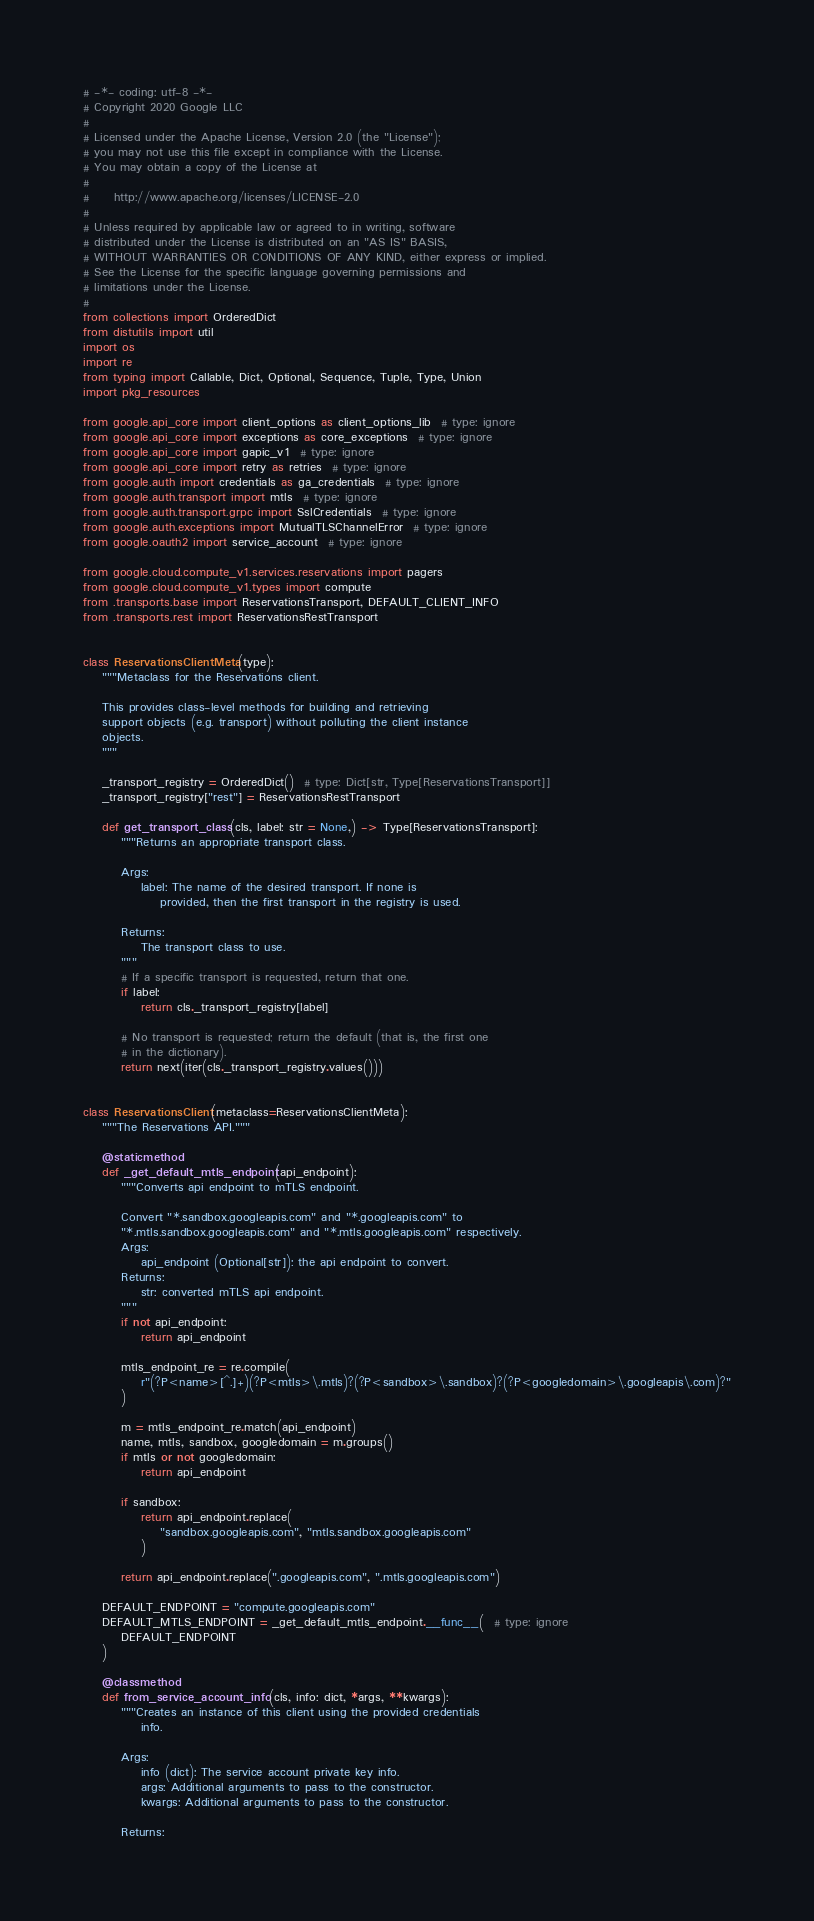Convert code to text. <code><loc_0><loc_0><loc_500><loc_500><_Python_># -*- coding: utf-8 -*-
# Copyright 2020 Google LLC
#
# Licensed under the Apache License, Version 2.0 (the "License");
# you may not use this file except in compliance with the License.
# You may obtain a copy of the License at
#
#     http://www.apache.org/licenses/LICENSE-2.0
#
# Unless required by applicable law or agreed to in writing, software
# distributed under the License is distributed on an "AS IS" BASIS,
# WITHOUT WARRANTIES OR CONDITIONS OF ANY KIND, either express or implied.
# See the License for the specific language governing permissions and
# limitations under the License.
#
from collections import OrderedDict
from distutils import util
import os
import re
from typing import Callable, Dict, Optional, Sequence, Tuple, Type, Union
import pkg_resources

from google.api_core import client_options as client_options_lib  # type: ignore
from google.api_core import exceptions as core_exceptions  # type: ignore
from google.api_core import gapic_v1  # type: ignore
from google.api_core import retry as retries  # type: ignore
from google.auth import credentials as ga_credentials  # type: ignore
from google.auth.transport import mtls  # type: ignore
from google.auth.transport.grpc import SslCredentials  # type: ignore
from google.auth.exceptions import MutualTLSChannelError  # type: ignore
from google.oauth2 import service_account  # type: ignore

from google.cloud.compute_v1.services.reservations import pagers
from google.cloud.compute_v1.types import compute
from .transports.base import ReservationsTransport, DEFAULT_CLIENT_INFO
from .transports.rest import ReservationsRestTransport


class ReservationsClientMeta(type):
    """Metaclass for the Reservations client.

    This provides class-level methods for building and retrieving
    support objects (e.g. transport) without polluting the client instance
    objects.
    """

    _transport_registry = OrderedDict()  # type: Dict[str, Type[ReservationsTransport]]
    _transport_registry["rest"] = ReservationsRestTransport

    def get_transport_class(cls, label: str = None,) -> Type[ReservationsTransport]:
        """Returns an appropriate transport class.

        Args:
            label: The name of the desired transport. If none is
                provided, then the first transport in the registry is used.

        Returns:
            The transport class to use.
        """
        # If a specific transport is requested, return that one.
        if label:
            return cls._transport_registry[label]

        # No transport is requested; return the default (that is, the first one
        # in the dictionary).
        return next(iter(cls._transport_registry.values()))


class ReservationsClient(metaclass=ReservationsClientMeta):
    """The Reservations API."""

    @staticmethod
    def _get_default_mtls_endpoint(api_endpoint):
        """Converts api endpoint to mTLS endpoint.

        Convert "*.sandbox.googleapis.com" and "*.googleapis.com" to
        "*.mtls.sandbox.googleapis.com" and "*.mtls.googleapis.com" respectively.
        Args:
            api_endpoint (Optional[str]): the api endpoint to convert.
        Returns:
            str: converted mTLS api endpoint.
        """
        if not api_endpoint:
            return api_endpoint

        mtls_endpoint_re = re.compile(
            r"(?P<name>[^.]+)(?P<mtls>\.mtls)?(?P<sandbox>\.sandbox)?(?P<googledomain>\.googleapis\.com)?"
        )

        m = mtls_endpoint_re.match(api_endpoint)
        name, mtls, sandbox, googledomain = m.groups()
        if mtls or not googledomain:
            return api_endpoint

        if sandbox:
            return api_endpoint.replace(
                "sandbox.googleapis.com", "mtls.sandbox.googleapis.com"
            )

        return api_endpoint.replace(".googleapis.com", ".mtls.googleapis.com")

    DEFAULT_ENDPOINT = "compute.googleapis.com"
    DEFAULT_MTLS_ENDPOINT = _get_default_mtls_endpoint.__func__(  # type: ignore
        DEFAULT_ENDPOINT
    )

    @classmethod
    def from_service_account_info(cls, info: dict, *args, **kwargs):
        """Creates an instance of this client using the provided credentials
            info.

        Args:
            info (dict): The service account private key info.
            args: Additional arguments to pass to the constructor.
            kwargs: Additional arguments to pass to the constructor.

        Returns:</code> 